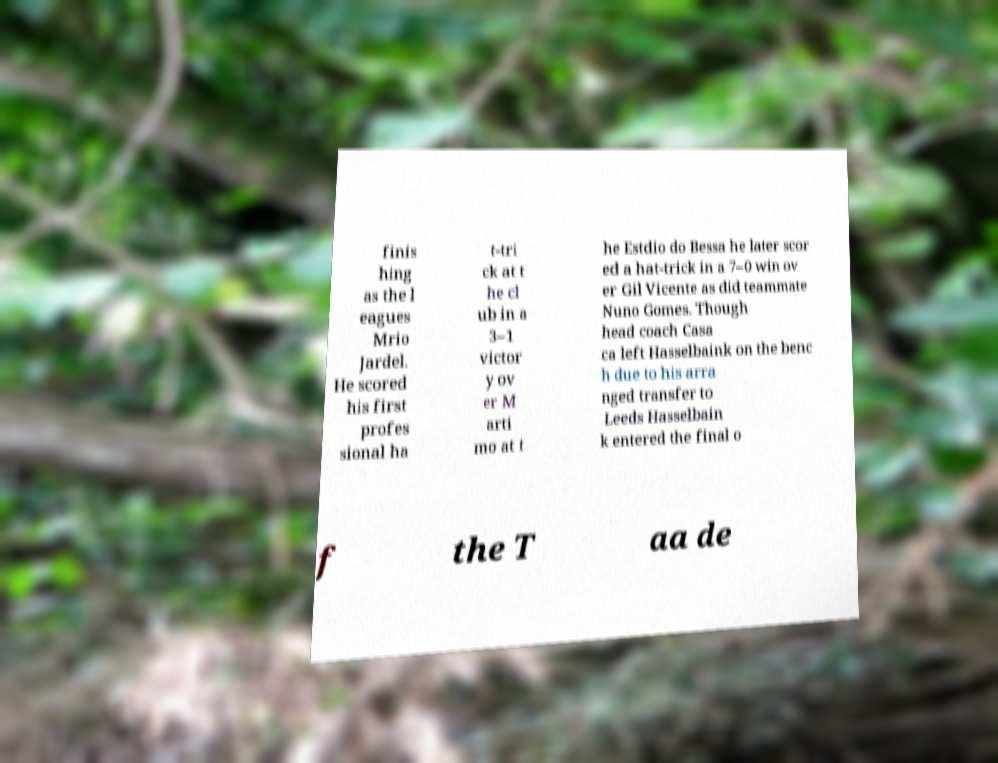Please read and relay the text visible in this image. What does it say? finis hing as the l eagues Mrio Jardel. He scored his first profes sional ha t-tri ck at t he cl ub in a 3–1 victor y ov er M arti mo at t he Estdio do Bessa he later scor ed a hat-trick in a 7–0 win ov er Gil Vicente as did teammate Nuno Gomes. Though head coach Casa ca left Hasselbaink on the benc h due to his arra nged transfer to Leeds Hasselbain k entered the final o f the T aa de 